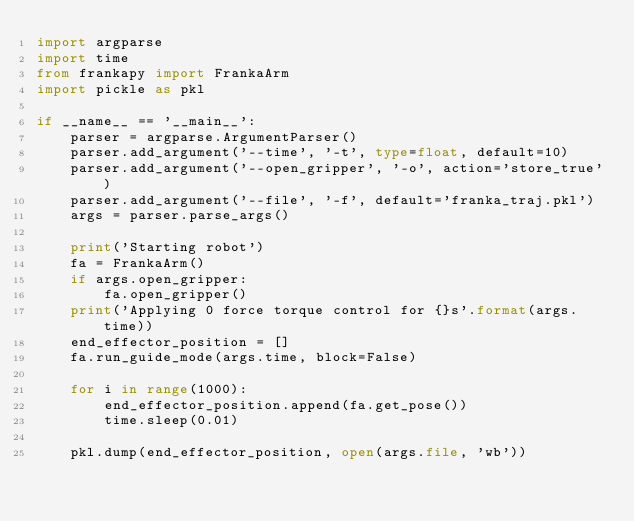<code> <loc_0><loc_0><loc_500><loc_500><_Python_>import argparse
import time
from frankapy import FrankaArm
import pickle as pkl

if __name__ == '__main__':
    parser = argparse.ArgumentParser()
    parser.add_argument('--time', '-t', type=float, default=10)
    parser.add_argument('--open_gripper', '-o', action='store_true')
    parser.add_argument('--file', '-f', default='franka_traj.pkl')
    args = parser.parse_args()

    print('Starting robot')
    fa = FrankaArm()
    if args.open_gripper:
        fa.open_gripper()
    print('Applying 0 force torque control for {}s'.format(args.time))
    end_effector_position = []
    fa.run_guide_mode(args.time, block=False)

    for i in range(1000):
        end_effector_position.append(fa.get_pose())
        time.sleep(0.01)

    pkl.dump(end_effector_position, open(args.file, 'wb'))</code> 